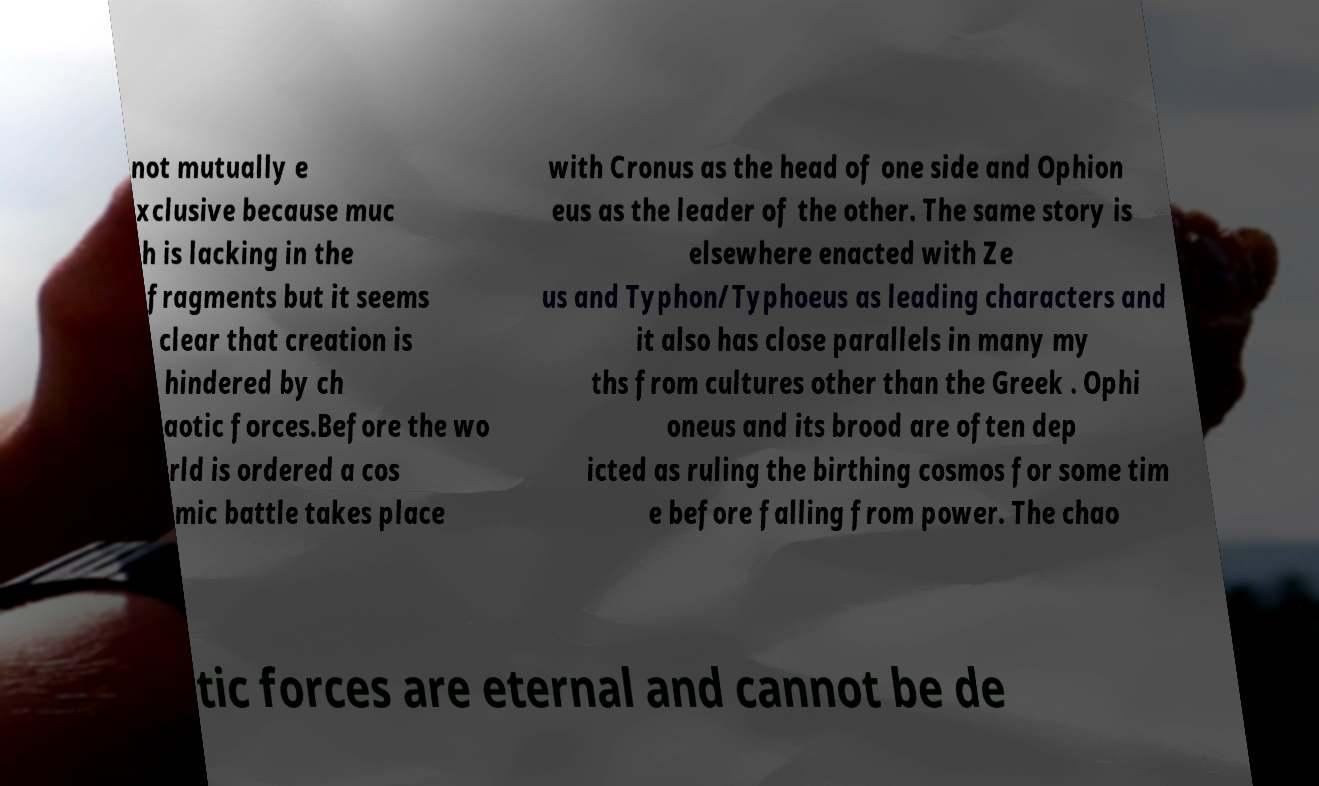I need the written content from this picture converted into text. Can you do that? not mutually e xclusive because muc h is lacking in the fragments but it seems clear that creation is hindered by ch aotic forces.Before the wo rld is ordered a cos mic battle takes place with Cronus as the head of one side and Ophion eus as the leader of the other. The same story is elsewhere enacted with Ze us and Typhon/Typhoeus as leading characters and it also has close parallels in many my ths from cultures other than the Greek . Ophi oneus and its brood are often dep icted as ruling the birthing cosmos for some tim e before falling from power. The chao tic forces are eternal and cannot be de 